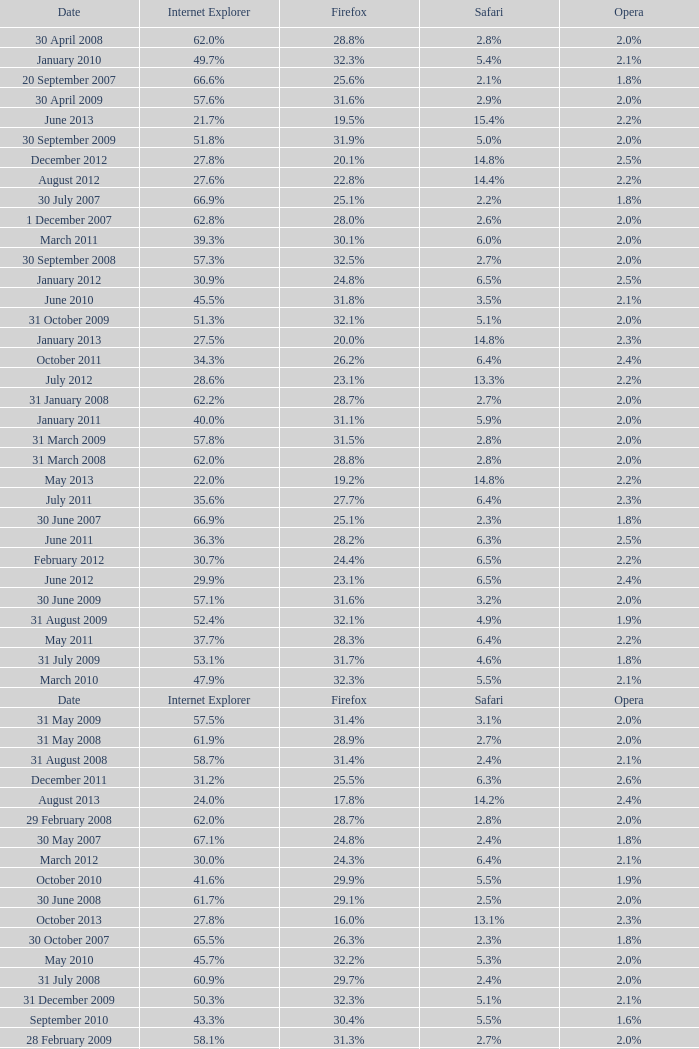What is the safari value with a 2.4% opera and 29.9% internet explorer? 6.5%. 